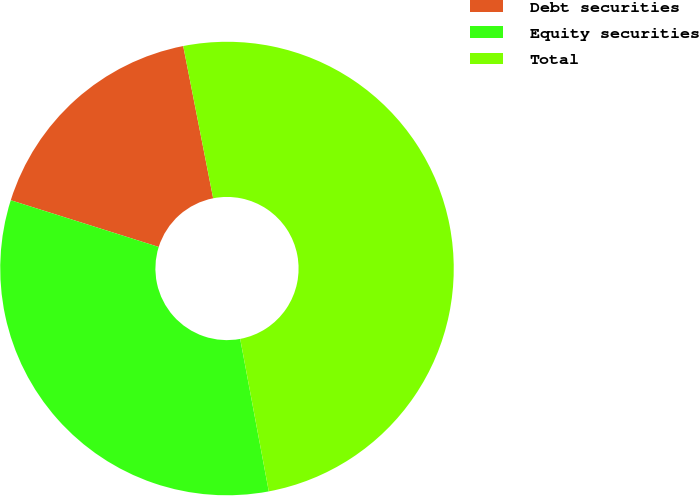Convert chart to OTSL. <chart><loc_0><loc_0><loc_500><loc_500><pie_chart><fcel>Debt securities<fcel>Equity securities<fcel>Total<nl><fcel>17.04%<fcel>32.82%<fcel>50.14%<nl></chart> 